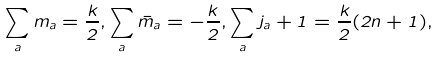Convert formula to latex. <formula><loc_0><loc_0><loc_500><loc_500>\sum _ { a } m _ { a } = \frac { k } { 2 } , \sum _ { a } \bar { m } _ { a } = - \frac { k } { 2 } , \sum _ { a } j _ { a } + 1 = \frac { k } { 2 } ( 2 n + 1 ) ,</formula> 